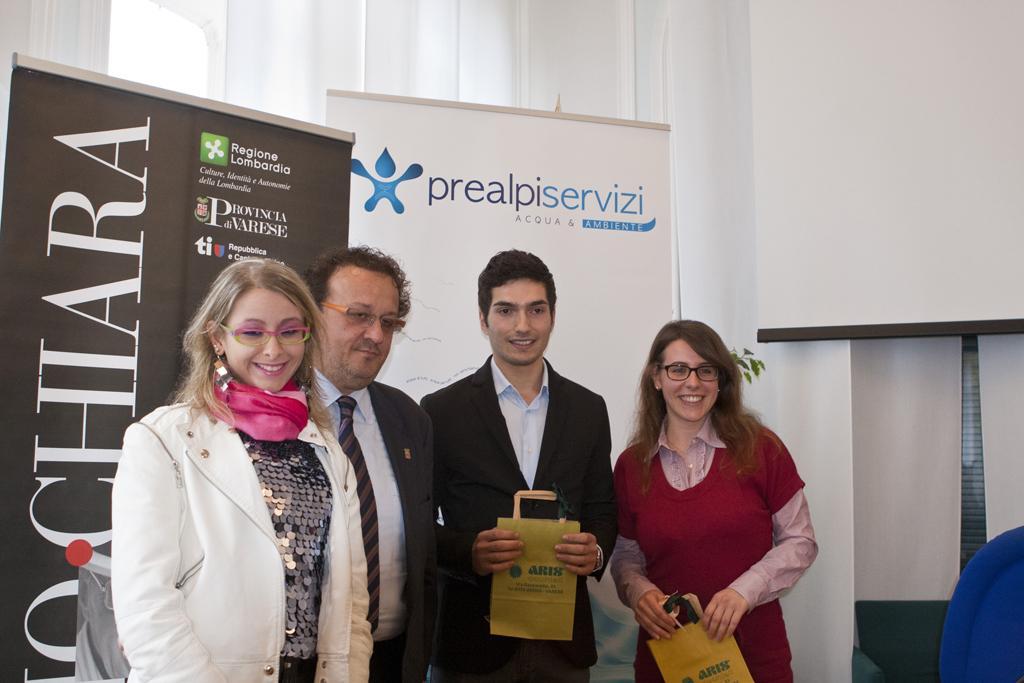Please provide a concise description of this image. In this image in the front there are persons standing and smiling. In the center there are boards with some text written on it and in the background there is a curtain which is white in colour and there is a wall which is white in colour. On the right side there is an object which is blue in colour. 